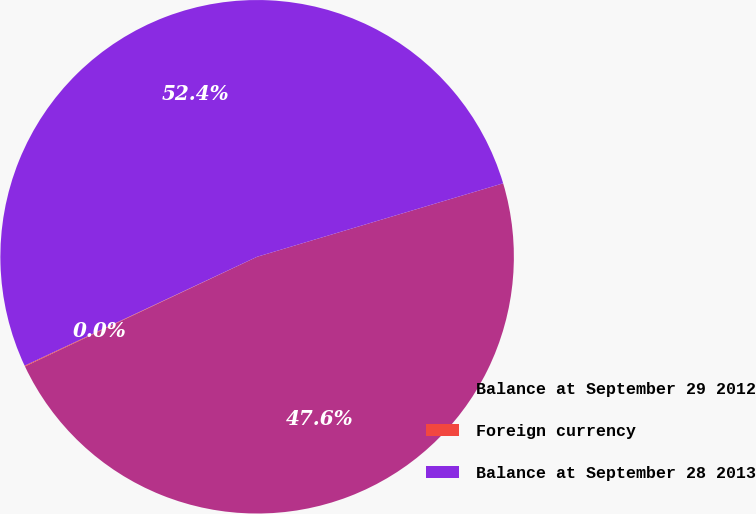Convert chart to OTSL. <chart><loc_0><loc_0><loc_500><loc_500><pie_chart><fcel>Balance at September 29 2012<fcel>Foreign currency<fcel>Balance at September 28 2013<nl><fcel>47.6%<fcel>0.05%<fcel>52.36%<nl></chart> 